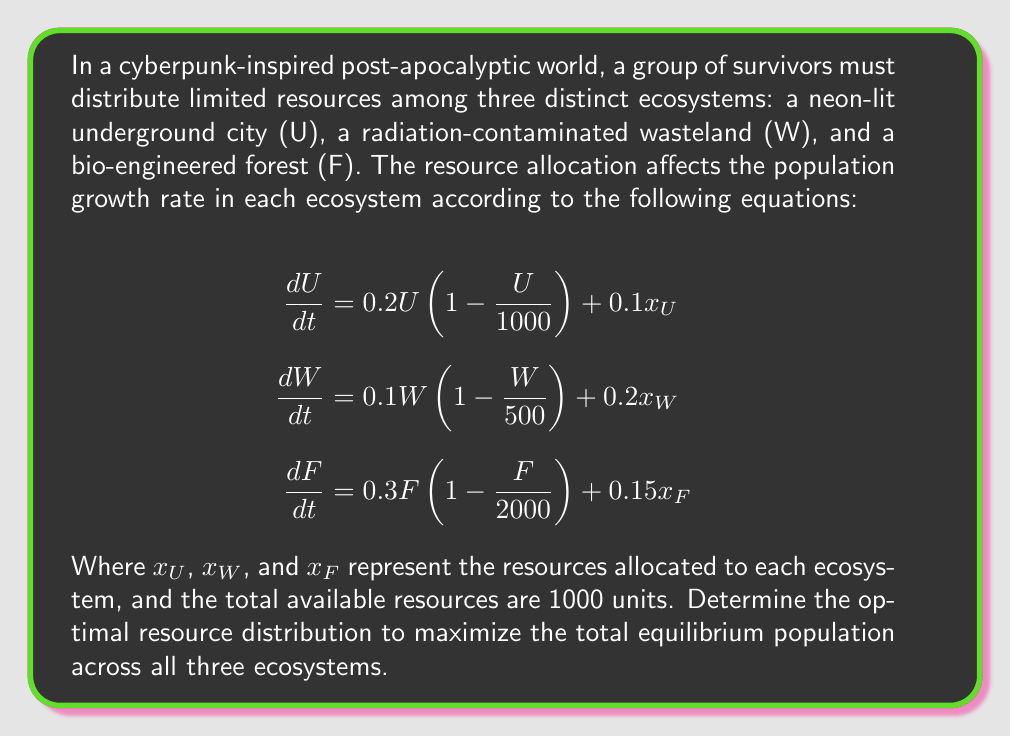Can you answer this question? To solve this problem, we need to follow these steps:

1. Find the equilibrium population for each ecosystem in terms of resource allocation:
   Set each equation to zero and solve for U, W, and F:
   
   For U: $0 = 0.2U(1 - \frac{U}{1000}) + 0.1x_U$
   $U = 1000(1 + 0.5x_U)$
   
   For W: $0 = 0.1W(1 - \frac{W}{500}) + 0.2x_W$
   $W = 500(1 + 2x_W)$
   
   For F: $0 = 0.3F(1 - \frac{F}{2000}) + 0.15x_F$
   $F = 2000(1 + 0.25x_F)$

2. Set up an optimization problem:
   Maximize: $T = U + W + F = 1000(1 + 0.5x_U) + 500(1 + 2x_W) + 2000(1 + 0.25x_F)$
   Subject to: $x_U + x_W + x_F = 1000$ and $x_U, x_W, x_F \geq 0$

3. Use the method of Lagrange multipliers:
   $L = 1000(1 + 0.5x_U) + 500(1 + 2x_W) + 2000(1 + 0.25x_F) - \lambda(x_U + x_W + x_F - 1000)$

4. Take partial derivatives and set them to zero:
   $\frac{\partial L}{\partial x_U} = 500 - \lambda = 0$
   $\frac{\partial L}{\partial x_W} = 1000 - \lambda = 0$
   $\frac{\partial L}{\partial x_F} = 500 - \lambda = 0$
   $\frac{\partial L}{\partial \lambda} = x_U + x_W + x_F - 1000 = 0$

5. Solve the system of equations:
   From the first three equations, we can see that $\lambda = 500 = 1000 = 500$
   This is only possible if $x_W = 0$ and $x_U = x_F$
   
   Substituting into the last equation:
   $x_U + x_F = 1000$
   $2x_U = 1000$
   $x_U = x_F = 500$

6. Verify that this is indeed the maximum:
   The second derivative test confirms this is a maximum point.

Therefore, the optimal resource distribution is 500 units to the underground city, 0 units to the wasteland, and 500 units to the bio-engineered forest.
Answer: The optimal resource distribution is:
$x_U = 500$ (Underground city)
$x_W = 0$ (Wasteland)
$x_F = 500$ (Bio-engineered forest)

This results in a total equilibrium population of:
$T = 1000(1 + 0.5 \cdot 500) + 500(1 + 2 \cdot 0) + 2000(1 + 0.25 \cdot 500) = 501,000$ 